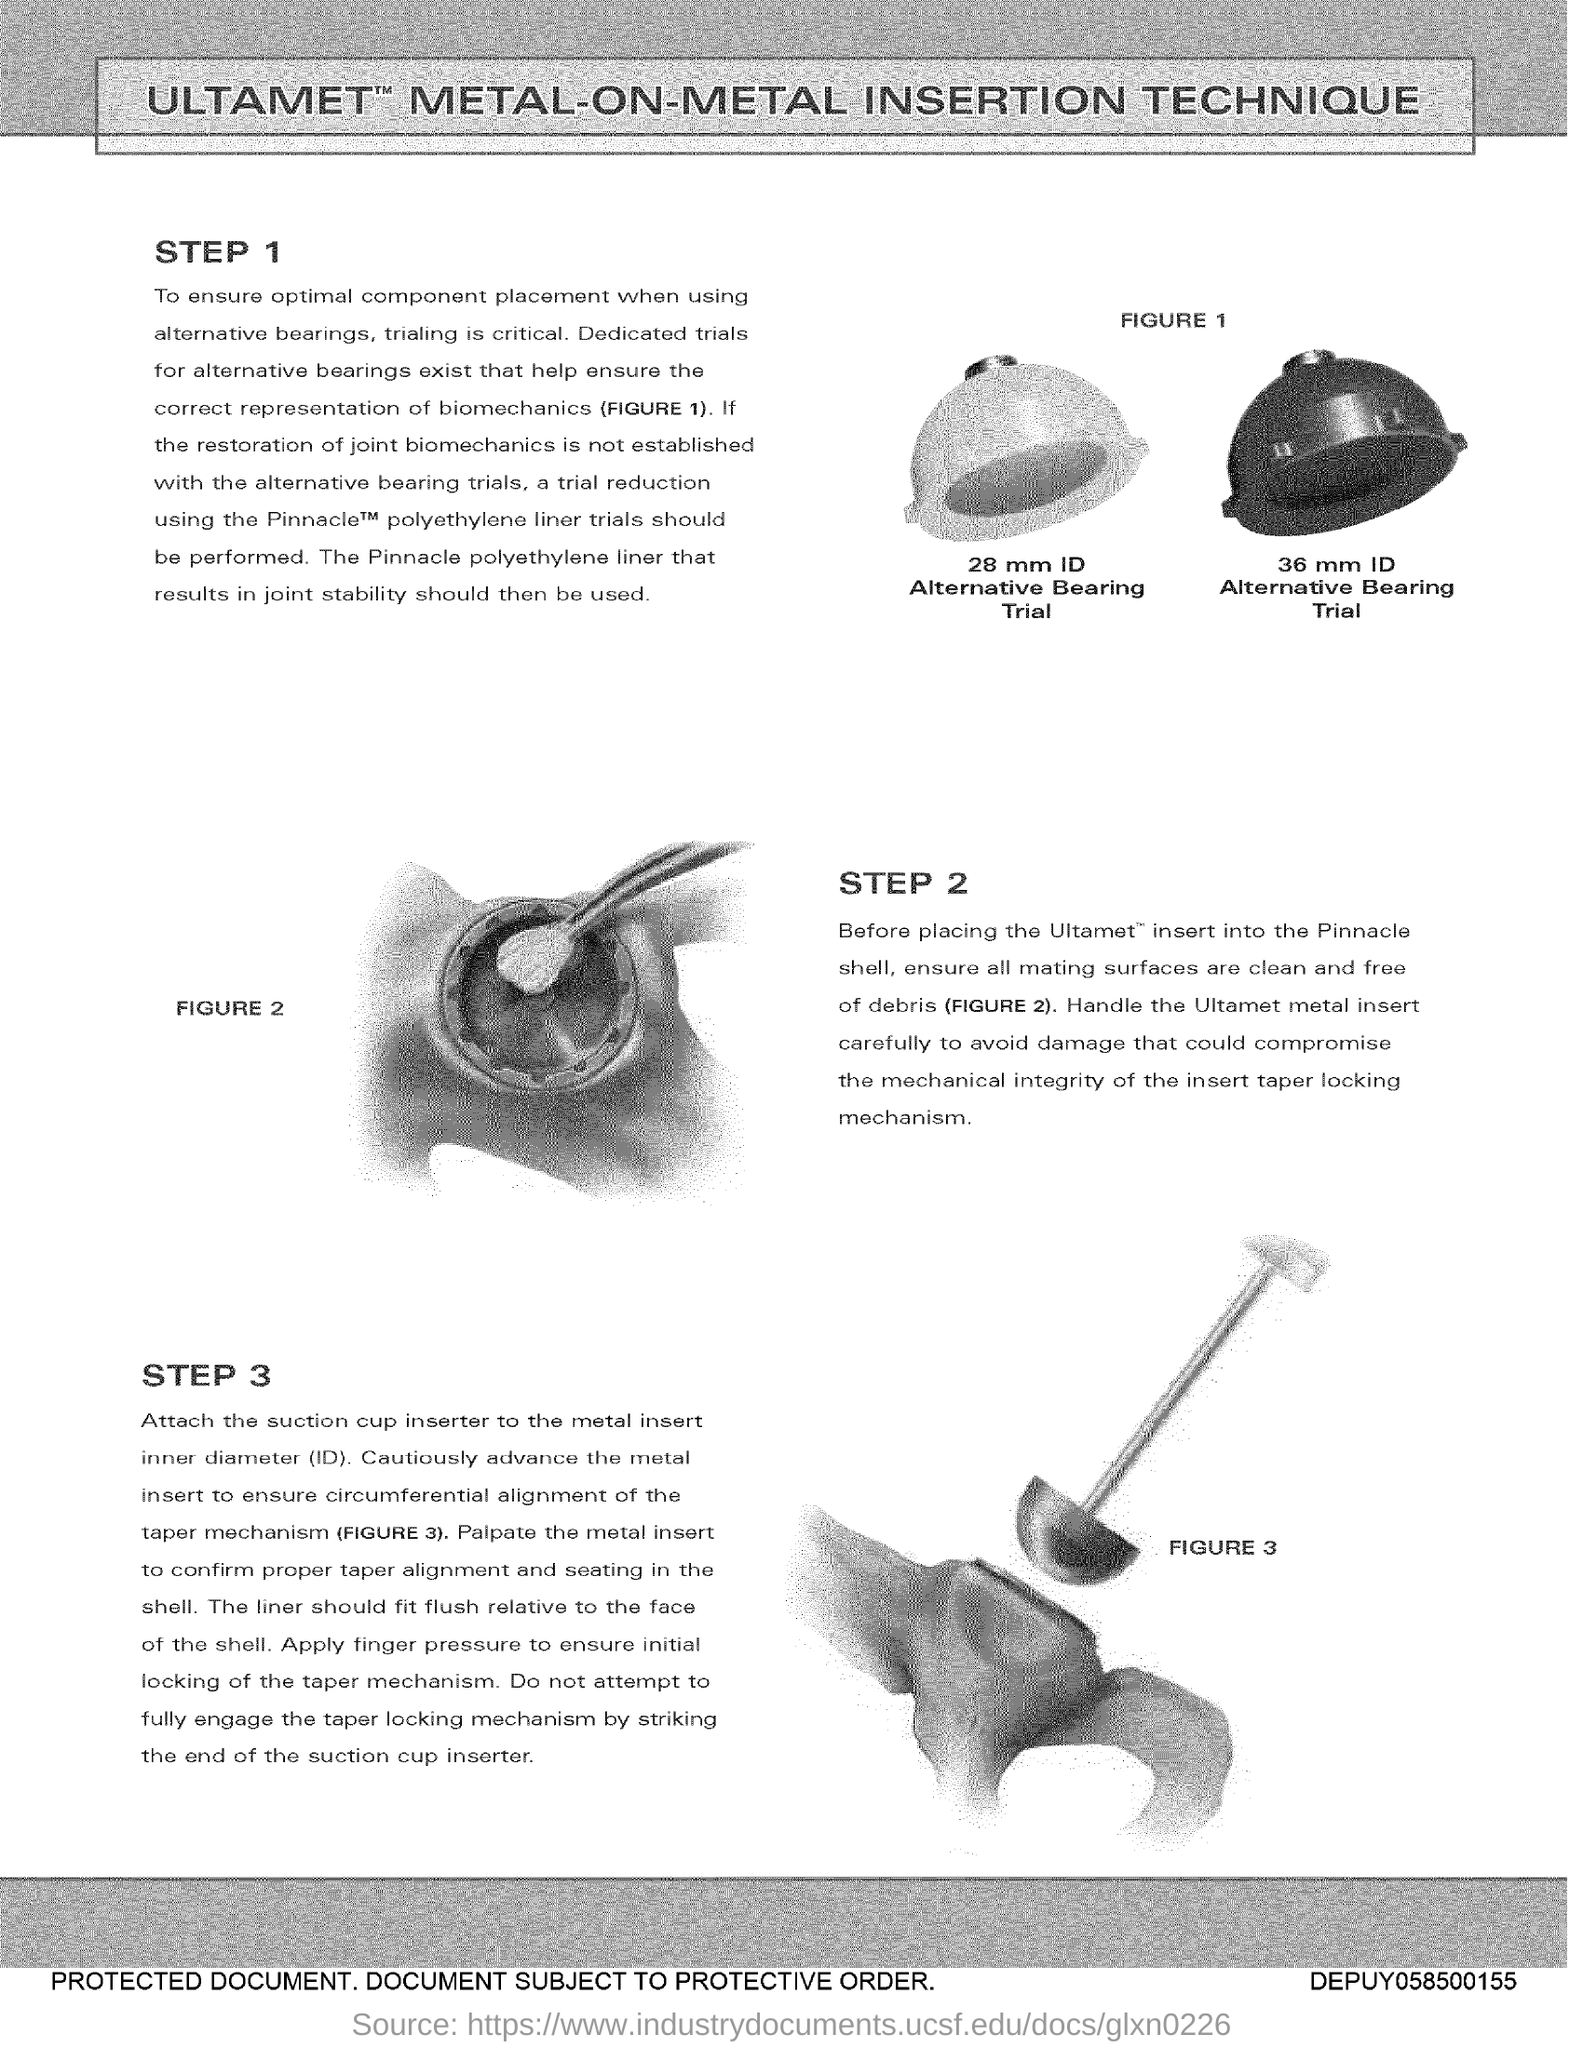Indicate a few pertinent items in this graphic. The document heading is 'Ultamet metal-on-metal insertion technique.' The procedure involves three steps. 